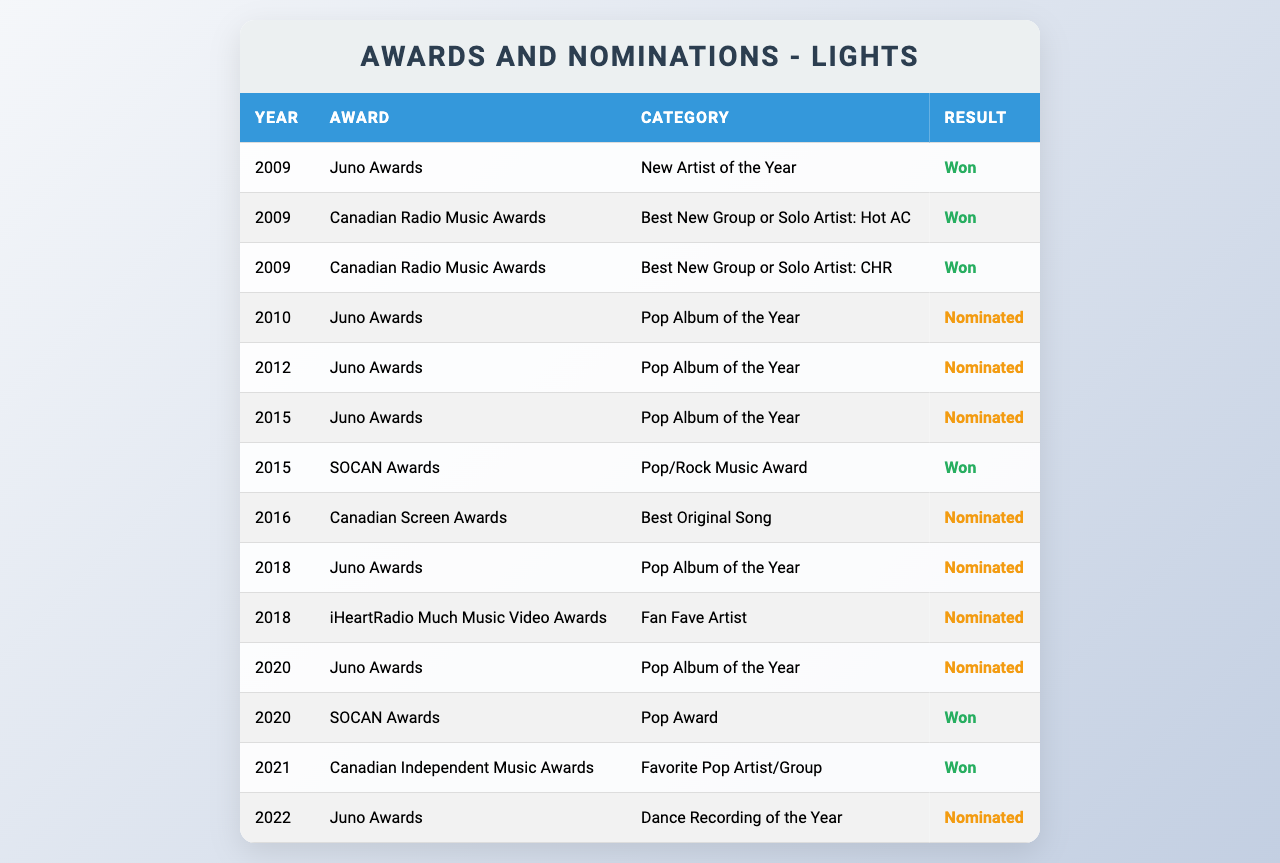What year did Lights win the Juno Award for New Artist of the Year? The table shows that Lights won the Juno Award for New Artist of the Year in the year 2009, as marked in the "Result" column.
Answer: 2009 How many times has Lights been nominated for a Juno Award? The table lists 6 instances where Lights was nominated for a Juno Award (2010, 2012, 2015, 2018, 2020, and 2022), which can be counted from the corresponding entries.
Answer: 6 Which award did Lights win in 2020? According to the table, Lights won the SOCAN Award for Pop Award in the year 2020, as indicated in the "Result" column.
Answer: SOCAN Award for Pop Award Which award categories has Lights been nominated for the most? By analyzing the table, Lights has been nominated 4 times for "Pop Album of the Year" at the Juno Awards, making it the most frequent category of nominations.
Answer: Pop Album of the Year Did Lights win more awards or nominations throughout her career? The table shows that Lights has won 6 awards and received 8 nominations, indicating that she has more nominations than wins overall.
Answer: More nominations What is the total number of awards and nominations received by Lights? To calculate the total, sum the wins (6) and nominations (8), giving a total of 14 awards and nominations combined.
Answer: 14 In which year did Lights achieve her last award win listed in the table? Referring to the table, the last award win recorded is in the year 2021, when she won the Canadian Independent Music Award for Favorite Pop Artist/Group.
Answer: 2021 Have there been more award wins in the 2010s or 2020s? Analyzing the data, Lights has 5 wins in the 2010s and 2 wins in the 2020s, so there are more wins in the 2010s.
Answer: 2010s What percentage of Juno nominations resulted in wins for Lights? Since Lights has received 6 Juno nominations and won 1 Juno Award, the percentage is (1/6) * 100 = approximately 16.67%.
Answer: 16.67% Did Lights win an award for Best Original Song at the Canadian Screen Awards? The table shows that Lights was nominated for Best Original Song at the Canadian Screen Awards in 2016 but did not win, as indicated by the "Result" column.
Answer: No 